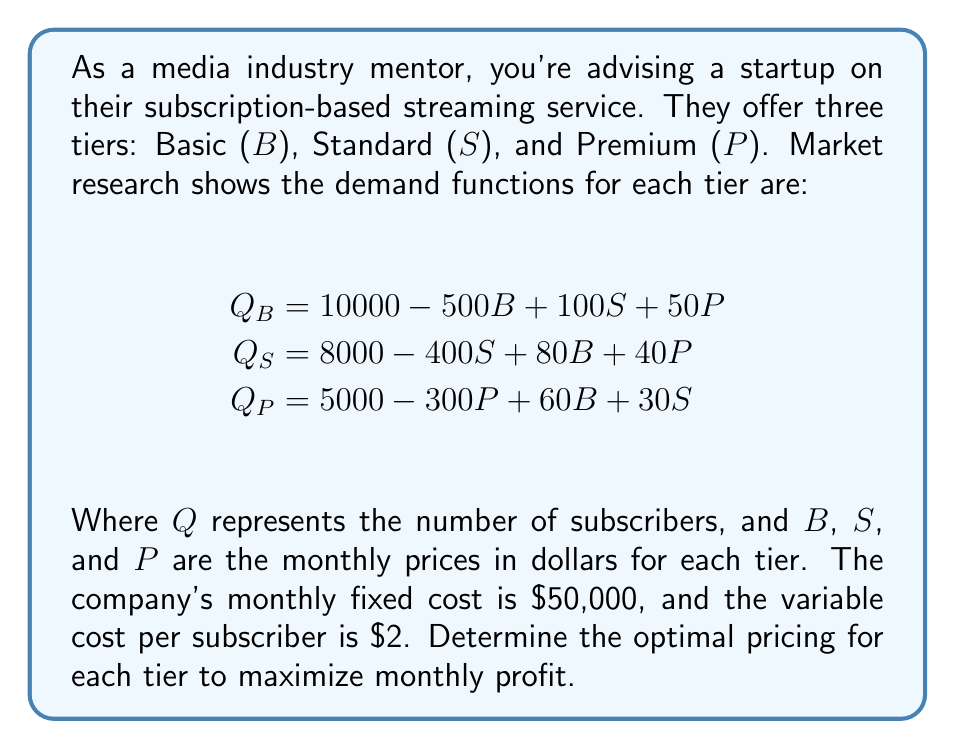Show me your answer to this math problem. Let's approach this step-by-step:

1) First, we need to formulate the profit function. Profit is revenue minus costs.

2) Revenue for each tier is price times quantity:
   $R_B = BQ_B$, $R_S = SQ_S$, $R_P = PQ_P$

3) Total revenue: $R = BQ_B + SQ_S + PQ_P$

4) Total cost: $C = 50000 + 2(Q_B + Q_S + Q_P)$

5) Profit function: $\pi = R - C$

6) Substituting the demand functions:

   $\pi = B(10000 - 500B + 100S + 50P) + S(8000 - 400S + 80B + 40P) + P(5000 - 300P + 60B + 30S) - 50000 - 2(23000 - 360B - 270S - 210P)$

7) Simplify:
   $\pi = 10000B - 500B^2 + 100BS + 50BP + 8000S - 400S^2 + 80BS + 40SP + 5000P - 300P^2 + 60BP + 30SP - 50000 + 720B + 540S + 420P - 46000$

8) To find the maximum profit, we need to find where the partial derivatives with respect to B, S, and P are zero:

   $\frac{\partial \pi}{\partial B} = 10720 - 1000B + 180S + 110P = 0$
   $\frac{\partial \pi}{\partial S} = 8540 - 800S + 180B + 70P = 0$
   $\frac{\partial \pi}{\partial P} = 5420 - 600P + 110B + 70S = 0$

9) Solve this system of equations. This can be done using matrix methods or substitution. The solution is:

   $B \approx 14.99$
   $S \approx 19.99$
   $P \approx 24.99$

10) Verify that the second partial derivatives are negative to confirm this is a maximum.
Answer: Basic: $14.99, Standard: $19.99, Premium: $24.99 